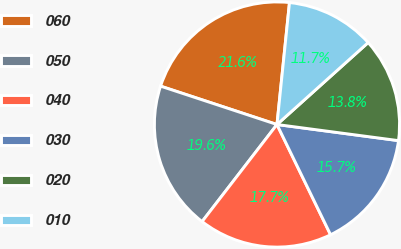Convert chart. <chart><loc_0><loc_0><loc_500><loc_500><pie_chart><fcel>060<fcel>050<fcel>040<fcel>030<fcel>020<fcel>010<nl><fcel>21.56%<fcel>19.61%<fcel>17.66%<fcel>15.7%<fcel>13.75%<fcel>11.72%<nl></chart> 